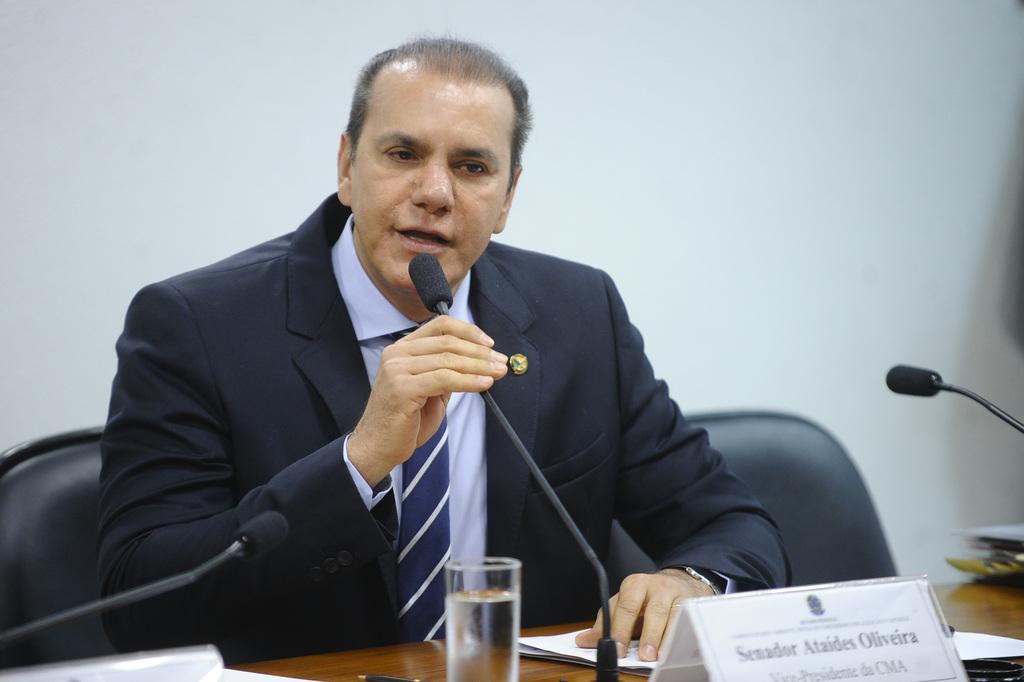Can you describe this image briefly? In this image, in the middle there is a man sitting on a chair which is in black color, he is holding a microphone which is in black color, he is speaking in the microphone, there is a glass on the table and there is a white color board on the table, in the background there is a white color wall. 